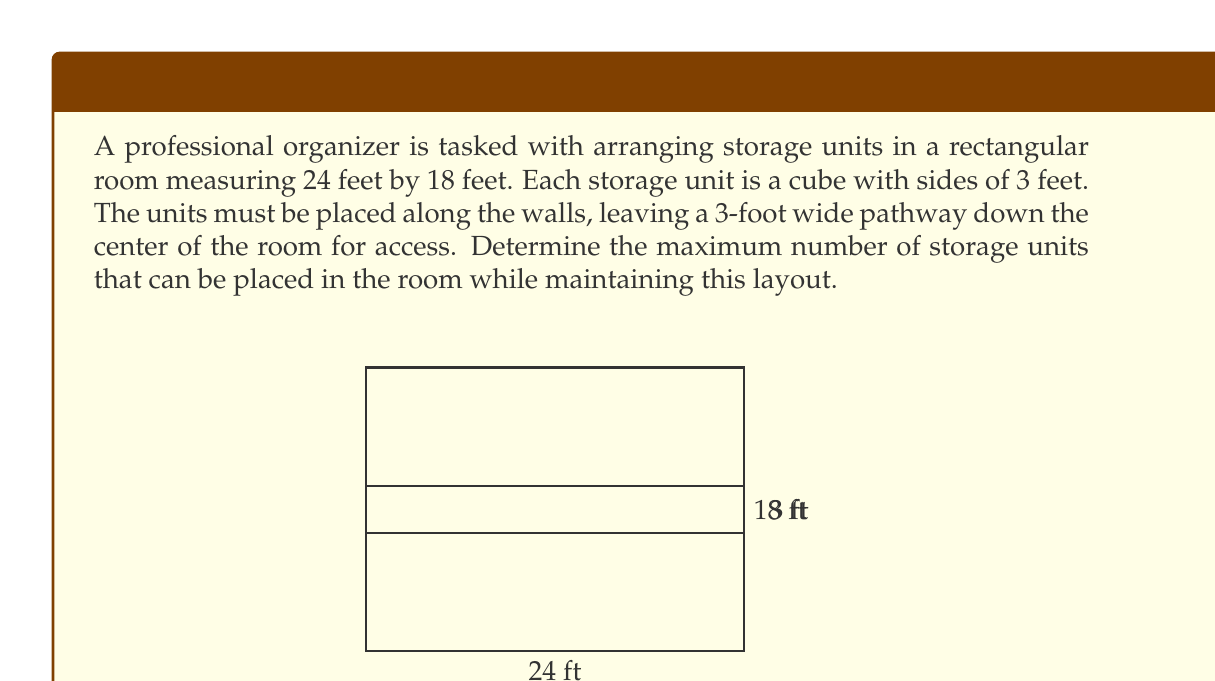Provide a solution to this math problem. Let's approach this problem step by step:

1) First, we need to calculate the available space for storage units:
   - The room is 24 feet long and 18 feet wide.
   - We need to subtract 3 feet from the width for the central pathway.
   - This leaves two strips of 7.5 feet wide on each side of the pathway.

2) Now, let's calculate how many units can fit along the length:
   - Each unit is 3 feet wide.
   - $24 \div 3 = 8$ units can fit along each long side.

3) For the short sides:
   - We have 7.5 feet of width available on each side.
   - $7.5 \div 3 = 2.5$, but we can only fit 2 whole units.

4) Let's calculate the total:
   - Long sides: $8 \times 2 = 16$ units
   - Short sides: $2 \times 2 = 4$ units

5) However, we need to subtract 4 units from this total because the corner units have been counted twice.

6) Therefore, the total number of units that can fit is:
   $16 + 4 - 4 = 16$ units

We can verify this by calculating the floor area occupied by the units:
$16 \times 3^2 = 144 \text{ sq ft}$

And the available floor area:
$24 \times 18 - 24 \times 3 = 360 \text{ sq ft}$

The units occupy less than half the floor space, leaving ample room for the pathway and maneuvering.
Answer: The maximum number of 3-foot cubic storage units that can be placed in the room is 16. 